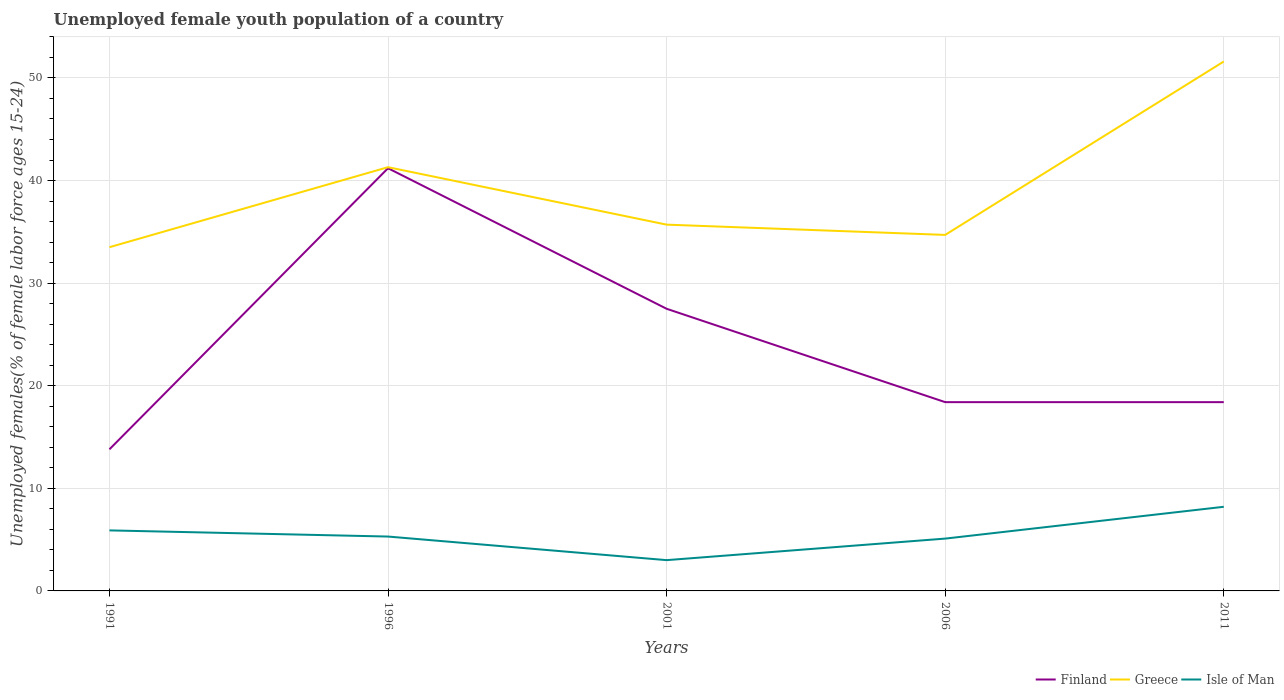How many different coloured lines are there?
Your response must be concise. 3. Does the line corresponding to Isle of Man intersect with the line corresponding to Finland?
Give a very brief answer. No. Across all years, what is the maximum percentage of unemployed female youth population in Greece?
Ensure brevity in your answer.  33.5. In which year was the percentage of unemployed female youth population in Isle of Man maximum?
Provide a short and direct response. 2001. What is the total percentage of unemployed female youth population in Finland in the graph?
Ensure brevity in your answer.  -4.6. What is the difference between the highest and the second highest percentage of unemployed female youth population in Isle of Man?
Keep it short and to the point. 5.2. What is the difference between the highest and the lowest percentage of unemployed female youth population in Isle of Man?
Offer a terse response. 2. Is the percentage of unemployed female youth population in Greece strictly greater than the percentage of unemployed female youth population in Finland over the years?
Your answer should be compact. No. What is the difference between two consecutive major ticks on the Y-axis?
Offer a very short reply. 10. Are the values on the major ticks of Y-axis written in scientific E-notation?
Ensure brevity in your answer.  No. Does the graph contain grids?
Provide a short and direct response. Yes. How are the legend labels stacked?
Keep it short and to the point. Horizontal. What is the title of the graph?
Offer a very short reply. Unemployed female youth population of a country. What is the label or title of the X-axis?
Make the answer very short. Years. What is the label or title of the Y-axis?
Offer a very short reply. Unemployed females(% of female labor force ages 15-24). What is the Unemployed females(% of female labor force ages 15-24) in Finland in 1991?
Offer a very short reply. 13.8. What is the Unemployed females(% of female labor force ages 15-24) of Greece in 1991?
Give a very brief answer. 33.5. What is the Unemployed females(% of female labor force ages 15-24) of Isle of Man in 1991?
Offer a very short reply. 5.9. What is the Unemployed females(% of female labor force ages 15-24) of Finland in 1996?
Make the answer very short. 41.2. What is the Unemployed females(% of female labor force ages 15-24) in Greece in 1996?
Your answer should be very brief. 41.3. What is the Unemployed females(% of female labor force ages 15-24) of Isle of Man in 1996?
Your answer should be very brief. 5.3. What is the Unemployed females(% of female labor force ages 15-24) in Greece in 2001?
Your response must be concise. 35.7. What is the Unemployed females(% of female labor force ages 15-24) in Isle of Man in 2001?
Ensure brevity in your answer.  3. What is the Unemployed females(% of female labor force ages 15-24) of Finland in 2006?
Your response must be concise. 18.4. What is the Unemployed females(% of female labor force ages 15-24) in Greece in 2006?
Offer a terse response. 34.7. What is the Unemployed females(% of female labor force ages 15-24) of Isle of Man in 2006?
Offer a very short reply. 5.1. What is the Unemployed females(% of female labor force ages 15-24) in Finland in 2011?
Keep it short and to the point. 18.4. What is the Unemployed females(% of female labor force ages 15-24) of Greece in 2011?
Make the answer very short. 51.6. What is the Unemployed females(% of female labor force ages 15-24) in Isle of Man in 2011?
Give a very brief answer. 8.2. Across all years, what is the maximum Unemployed females(% of female labor force ages 15-24) in Finland?
Offer a very short reply. 41.2. Across all years, what is the maximum Unemployed females(% of female labor force ages 15-24) of Greece?
Provide a succinct answer. 51.6. Across all years, what is the maximum Unemployed females(% of female labor force ages 15-24) in Isle of Man?
Make the answer very short. 8.2. Across all years, what is the minimum Unemployed females(% of female labor force ages 15-24) of Finland?
Give a very brief answer. 13.8. Across all years, what is the minimum Unemployed females(% of female labor force ages 15-24) of Greece?
Your response must be concise. 33.5. What is the total Unemployed females(% of female labor force ages 15-24) in Finland in the graph?
Your answer should be compact. 119.3. What is the total Unemployed females(% of female labor force ages 15-24) in Greece in the graph?
Make the answer very short. 196.8. What is the total Unemployed females(% of female labor force ages 15-24) in Isle of Man in the graph?
Ensure brevity in your answer.  27.5. What is the difference between the Unemployed females(% of female labor force ages 15-24) in Finland in 1991 and that in 1996?
Give a very brief answer. -27.4. What is the difference between the Unemployed females(% of female labor force ages 15-24) in Greece in 1991 and that in 1996?
Give a very brief answer. -7.8. What is the difference between the Unemployed females(% of female labor force ages 15-24) in Isle of Man in 1991 and that in 1996?
Make the answer very short. 0.6. What is the difference between the Unemployed females(% of female labor force ages 15-24) in Finland in 1991 and that in 2001?
Give a very brief answer. -13.7. What is the difference between the Unemployed females(% of female labor force ages 15-24) of Greece in 1991 and that in 2001?
Your answer should be compact. -2.2. What is the difference between the Unemployed females(% of female labor force ages 15-24) in Finland in 1991 and that in 2006?
Make the answer very short. -4.6. What is the difference between the Unemployed females(% of female labor force ages 15-24) in Isle of Man in 1991 and that in 2006?
Make the answer very short. 0.8. What is the difference between the Unemployed females(% of female labor force ages 15-24) in Greece in 1991 and that in 2011?
Your answer should be very brief. -18.1. What is the difference between the Unemployed females(% of female labor force ages 15-24) in Finland in 1996 and that in 2006?
Your answer should be very brief. 22.8. What is the difference between the Unemployed females(% of female labor force ages 15-24) in Greece in 1996 and that in 2006?
Your answer should be compact. 6.6. What is the difference between the Unemployed females(% of female labor force ages 15-24) in Isle of Man in 1996 and that in 2006?
Your response must be concise. 0.2. What is the difference between the Unemployed females(% of female labor force ages 15-24) of Finland in 1996 and that in 2011?
Offer a very short reply. 22.8. What is the difference between the Unemployed females(% of female labor force ages 15-24) in Greece in 1996 and that in 2011?
Offer a very short reply. -10.3. What is the difference between the Unemployed females(% of female labor force ages 15-24) in Isle of Man in 1996 and that in 2011?
Provide a short and direct response. -2.9. What is the difference between the Unemployed females(% of female labor force ages 15-24) of Finland in 2001 and that in 2006?
Provide a succinct answer. 9.1. What is the difference between the Unemployed females(% of female labor force ages 15-24) of Finland in 2001 and that in 2011?
Make the answer very short. 9.1. What is the difference between the Unemployed females(% of female labor force ages 15-24) in Greece in 2001 and that in 2011?
Provide a succinct answer. -15.9. What is the difference between the Unemployed females(% of female labor force ages 15-24) in Isle of Man in 2001 and that in 2011?
Your answer should be compact. -5.2. What is the difference between the Unemployed females(% of female labor force ages 15-24) in Greece in 2006 and that in 2011?
Your response must be concise. -16.9. What is the difference between the Unemployed females(% of female labor force ages 15-24) of Finland in 1991 and the Unemployed females(% of female labor force ages 15-24) of Greece in 1996?
Provide a short and direct response. -27.5. What is the difference between the Unemployed females(% of female labor force ages 15-24) of Greece in 1991 and the Unemployed females(% of female labor force ages 15-24) of Isle of Man in 1996?
Your answer should be compact. 28.2. What is the difference between the Unemployed females(% of female labor force ages 15-24) in Finland in 1991 and the Unemployed females(% of female labor force ages 15-24) in Greece in 2001?
Offer a very short reply. -21.9. What is the difference between the Unemployed females(% of female labor force ages 15-24) in Greece in 1991 and the Unemployed females(% of female labor force ages 15-24) in Isle of Man in 2001?
Your answer should be very brief. 30.5. What is the difference between the Unemployed females(% of female labor force ages 15-24) of Finland in 1991 and the Unemployed females(% of female labor force ages 15-24) of Greece in 2006?
Keep it short and to the point. -20.9. What is the difference between the Unemployed females(% of female labor force ages 15-24) in Greece in 1991 and the Unemployed females(% of female labor force ages 15-24) in Isle of Man in 2006?
Your answer should be very brief. 28.4. What is the difference between the Unemployed females(% of female labor force ages 15-24) in Finland in 1991 and the Unemployed females(% of female labor force ages 15-24) in Greece in 2011?
Your response must be concise. -37.8. What is the difference between the Unemployed females(% of female labor force ages 15-24) of Greece in 1991 and the Unemployed females(% of female labor force ages 15-24) of Isle of Man in 2011?
Your response must be concise. 25.3. What is the difference between the Unemployed females(% of female labor force ages 15-24) of Finland in 1996 and the Unemployed females(% of female labor force ages 15-24) of Greece in 2001?
Provide a succinct answer. 5.5. What is the difference between the Unemployed females(% of female labor force ages 15-24) in Finland in 1996 and the Unemployed females(% of female labor force ages 15-24) in Isle of Man in 2001?
Keep it short and to the point. 38.2. What is the difference between the Unemployed females(% of female labor force ages 15-24) of Greece in 1996 and the Unemployed females(% of female labor force ages 15-24) of Isle of Man in 2001?
Provide a succinct answer. 38.3. What is the difference between the Unemployed females(% of female labor force ages 15-24) in Finland in 1996 and the Unemployed females(% of female labor force ages 15-24) in Isle of Man in 2006?
Make the answer very short. 36.1. What is the difference between the Unemployed females(% of female labor force ages 15-24) in Greece in 1996 and the Unemployed females(% of female labor force ages 15-24) in Isle of Man in 2006?
Keep it short and to the point. 36.2. What is the difference between the Unemployed females(% of female labor force ages 15-24) in Finland in 1996 and the Unemployed females(% of female labor force ages 15-24) in Greece in 2011?
Give a very brief answer. -10.4. What is the difference between the Unemployed females(% of female labor force ages 15-24) of Finland in 1996 and the Unemployed females(% of female labor force ages 15-24) of Isle of Man in 2011?
Keep it short and to the point. 33. What is the difference between the Unemployed females(% of female labor force ages 15-24) of Greece in 1996 and the Unemployed females(% of female labor force ages 15-24) of Isle of Man in 2011?
Ensure brevity in your answer.  33.1. What is the difference between the Unemployed females(% of female labor force ages 15-24) of Finland in 2001 and the Unemployed females(% of female labor force ages 15-24) of Greece in 2006?
Offer a very short reply. -7.2. What is the difference between the Unemployed females(% of female labor force ages 15-24) of Finland in 2001 and the Unemployed females(% of female labor force ages 15-24) of Isle of Man in 2006?
Make the answer very short. 22.4. What is the difference between the Unemployed females(% of female labor force ages 15-24) of Greece in 2001 and the Unemployed females(% of female labor force ages 15-24) of Isle of Man in 2006?
Offer a very short reply. 30.6. What is the difference between the Unemployed females(% of female labor force ages 15-24) in Finland in 2001 and the Unemployed females(% of female labor force ages 15-24) in Greece in 2011?
Keep it short and to the point. -24.1. What is the difference between the Unemployed females(% of female labor force ages 15-24) of Finland in 2001 and the Unemployed females(% of female labor force ages 15-24) of Isle of Man in 2011?
Make the answer very short. 19.3. What is the difference between the Unemployed females(% of female labor force ages 15-24) of Finland in 2006 and the Unemployed females(% of female labor force ages 15-24) of Greece in 2011?
Make the answer very short. -33.2. What is the difference between the Unemployed females(% of female labor force ages 15-24) of Finland in 2006 and the Unemployed females(% of female labor force ages 15-24) of Isle of Man in 2011?
Offer a terse response. 10.2. What is the difference between the Unemployed females(% of female labor force ages 15-24) of Greece in 2006 and the Unemployed females(% of female labor force ages 15-24) of Isle of Man in 2011?
Keep it short and to the point. 26.5. What is the average Unemployed females(% of female labor force ages 15-24) of Finland per year?
Give a very brief answer. 23.86. What is the average Unemployed females(% of female labor force ages 15-24) in Greece per year?
Your answer should be very brief. 39.36. What is the average Unemployed females(% of female labor force ages 15-24) of Isle of Man per year?
Keep it short and to the point. 5.5. In the year 1991, what is the difference between the Unemployed females(% of female labor force ages 15-24) in Finland and Unemployed females(% of female labor force ages 15-24) in Greece?
Give a very brief answer. -19.7. In the year 1991, what is the difference between the Unemployed females(% of female labor force ages 15-24) of Finland and Unemployed females(% of female labor force ages 15-24) of Isle of Man?
Make the answer very short. 7.9. In the year 1991, what is the difference between the Unemployed females(% of female labor force ages 15-24) in Greece and Unemployed females(% of female labor force ages 15-24) in Isle of Man?
Your answer should be compact. 27.6. In the year 1996, what is the difference between the Unemployed females(% of female labor force ages 15-24) of Finland and Unemployed females(% of female labor force ages 15-24) of Greece?
Offer a very short reply. -0.1. In the year 1996, what is the difference between the Unemployed females(% of female labor force ages 15-24) in Finland and Unemployed females(% of female labor force ages 15-24) in Isle of Man?
Keep it short and to the point. 35.9. In the year 2001, what is the difference between the Unemployed females(% of female labor force ages 15-24) in Finland and Unemployed females(% of female labor force ages 15-24) in Isle of Man?
Give a very brief answer. 24.5. In the year 2001, what is the difference between the Unemployed females(% of female labor force ages 15-24) in Greece and Unemployed females(% of female labor force ages 15-24) in Isle of Man?
Your response must be concise. 32.7. In the year 2006, what is the difference between the Unemployed females(% of female labor force ages 15-24) in Finland and Unemployed females(% of female labor force ages 15-24) in Greece?
Offer a terse response. -16.3. In the year 2006, what is the difference between the Unemployed females(% of female labor force ages 15-24) of Finland and Unemployed females(% of female labor force ages 15-24) of Isle of Man?
Provide a short and direct response. 13.3. In the year 2006, what is the difference between the Unemployed females(% of female labor force ages 15-24) of Greece and Unemployed females(% of female labor force ages 15-24) of Isle of Man?
Your response must be concise. 29.6. In the year 2011, what is the difference between the Unemployed females(% of female labor force ages 15-24) in Finland and Unemployed females(% of female labor force ages 15-24) in Greece?
Your answer should be compact. -33.2. In the year 2011, what is the difference between the Unemployed females(% of female labor force ages 15-24) of Finland and Unemployed females(% of female labor force ages 15-24) of Isle of Man?
Your response must be concise. 10.2. In the year 2011, what is the difference between the Unemployed females(% of female labor force ages 15-24) of Greece and Unemployed females(% of female labor force ages 15-24) of Isle of Man?
Provide a succinct answer. 43.4. What is the ratio of the Unemployed females(% of female labor force ages 15-24) in Finland in 1991 to that in 1996?
Offer a terse response. 0.34. What is the ratio of the Unemployed females(% of female labor force ages 15-24) of Greece in 1991 to that in 1996?
Offer a very short reply. 0.81. What is the ratio of the Unemployed females(% of female labor force ages 15-24) of Isle of Man in 1991 to that in 1996?
Ensure brevity in your answer.  1.11. What is the ratio of the Unemployed females(% of female labor force ages 15-24) of Finland in 1991 to that in 2001?
Give a very brief answer. 0.5. What is the ratio of the Unemployed females(% of female labor force ages 15-24) of Greece in 1991 to that in 2001?
Offer a terse response. 0.94. What is the ratio of the Unemployed females(% of female labor force ages 15-24) in Isle of Man in 1991 to that in 2001?
Ensure brevity in your answer.  1.97. What is the ratio of the Unemployed females(% of female labor force ages 15-24) of Finland in 1991 to that in 2006?
Your response must be concise. 0.75. What is the ratio of the Unemployed females(% of female labor force ages 15-24) of Greece in 1991 to that in 2006?
Your answer should be compact. 0.97. What is the ratio of the Unemployed females(% of female labor force ages 15-24) of Isle of Man in 1991 to that in 2006?
Keep it short and to the point. 1.16. What is the ratio of the Unemployed females(% of female labor force ages 15-24) of Finland in 1991 to that in 2011?
Offer a terse response. 0.75. What is the ratio of the Unemployed females(% of female labor force ages 15-24) in Greece in 1991 to that in 2011?
Your response must be concise. 0.65. What is the ratio of the Unemployed females(% of female labor force ages 15-24) in Isle of Man in 1991 to that in 2011?
Your response must be concise. 0.72. What is the ratio of the Unemployed females(% of female labor force ages 15-24) in Finland in 1996 to that in 2001?
Give a very brief answer. 1.5. What is the ratio of the Unemployed females(% of female labor force ages 15-24) of Greece in 1996 to that in 2001?
Ensure brevity in your answer.  1.16. What is the ratio of the Unemployed females(% of female labor force ages 15-24) in Isle of Man in 1996 to that in 2001?
Ensure brevity in your answer.  1.77. What is the ratio of the Unemployed females(% of female labor force ages 15-24) of Finland in 1996 to that in 2006?
Offer a very short reply. 2.24. What is the ratio of the Unemployed females(% of female labor force ages 15-24) in Greece in 1996 to that in 2006?
Make the answer very short. 1.19. What is the ratio of the Unemployed females(% of female labor force ages 15-24) in Isle of Man in 1996 to that in 2006?
Your answer should be compact. 1.04. What is the ratio of the Unemployed females(% of female labor force ages 15-24) in Finland in 1996 to that in 2011?
Provide a succinct answer. 2.24. What is the ratio of the Unemployed females(% of female labor force ages 15-24) in Greece in 1996 to that in 2011?
Keep it short and to the point. 0.8. What is the ratio of the Unemployed females(% of female labor force ages 15-24) in Isle of Man in 1996 to that in 2011?
Provide a short and direct response. 0.65. What is the ratio of the Unemployed females(% of female labor force ages 15-24) of Finland in 2001 to that in 2006?
Provide a succinct answer. 1.49. What is the ratio of the Unemployed females(% of female labor force ages 15-24) in Greece in 2001 to that in 2006?
Provide a short and direct response. 1.03. What is the ratio of the Unemployed females(% of female labor force ages 15-24) of Isle of Man in 2001 to that in 2006?
Give a very brief answer. 0.59. What is the ratio of the Unemployed females(% of female labor force ages 15-24) of Finland in 2001 to that in 2011?
Offer a terse response. 1.49. What is the ratio of the Unemployed females(% of female labor force ages 15-24) of Greece in 2001 to that in 2011?
Provide a short and direct response. 0.69. What is the ratio of the Unemployed females(% of female labor force ages 15-24) in Isle of Man in 2001 to that in 2011?
Offer a terse response. 0.37. What is the ratio of the Unemployed females(% of female labor force ages 15-24) of Greece in 2006 to that in 2011?
Ensure brevity in your answer.  0.67. What is the ratio of the Unemployed females(% of female labor force ages 15-24) in Isle of Man in 2006 to that in 2011?
Your answer should be compact. 0.62. What is the difference between the highest and the second highest Unemployed females(% of female labor force ages 15-24) in Greece?
Keep it short and to the point. 10.3. What is the difference between the highest and the second highest Unemployed females(% of female labor force ages 15-24) in Isle of Man?
Provide a succinct answer. 2.3. What is the difference between the highest and the lowest Unemployed females(% of female labor force ages 15-24) in Finland?
Offer a very short reply. 27.4. What is the difference between the highest and the lowest Unemployed females(% of female labor force ages 15-24) in Greece?
Provide a short and direct response. 18.1. 